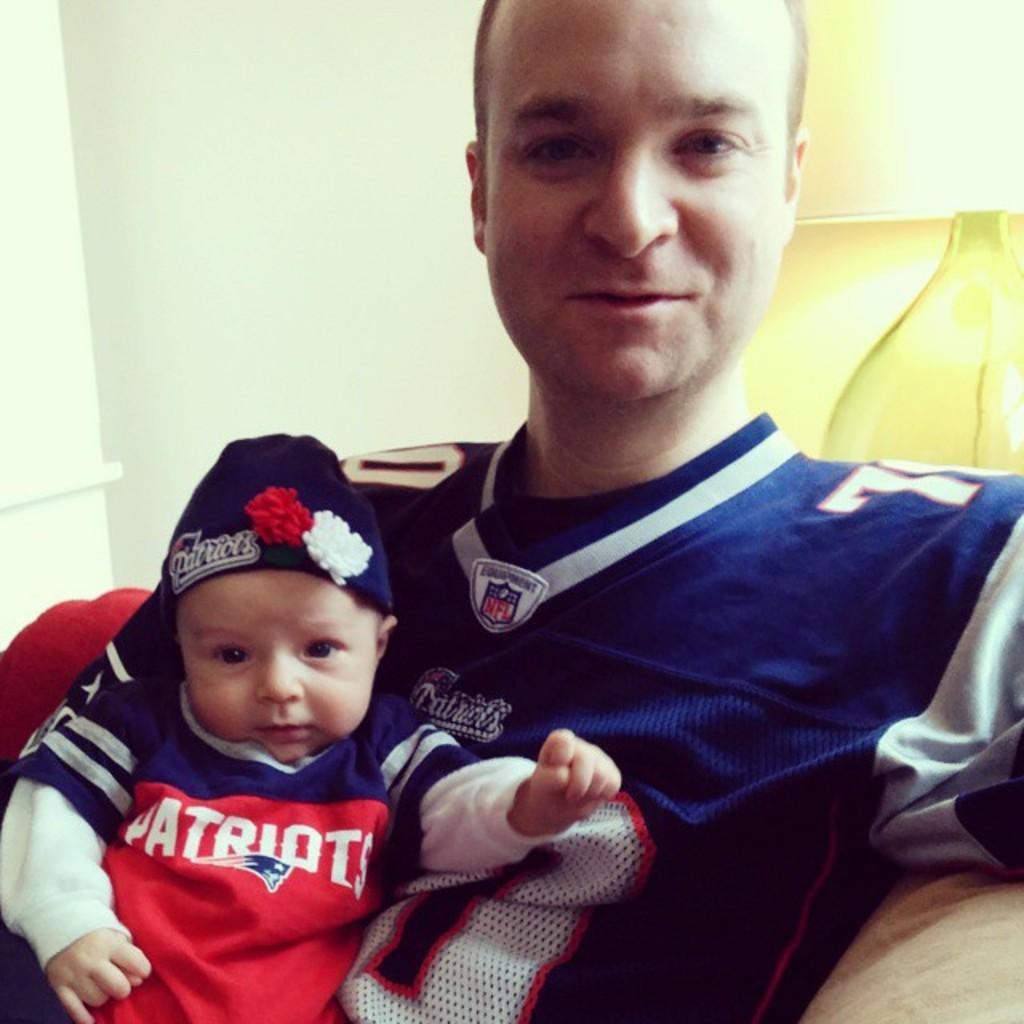What league is on the man's jersey?
Your answer should be compact. Nfl. 